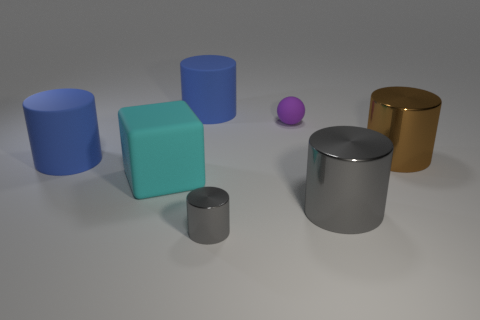Subtract all rubber cylinders. How many cylinders are left? 3 Add 2 green metal spheres. How many objects exist? 9 Subtract all brown cylinders. How many cylinders are left? 4 Subtract all cyan cubes. How many blue cylinders are left? 2 Subtract all blocks. How many objects are left? 6 Subtract 1 blocks. How many blocks are left? 0 Subtract 0 gray blocks. How many objects are left? 7 Subtract all cyan spheres. Subtract all blue cylinders. How many spheres are left? 1 Subtract all large blue rubber balls. Subtract all large cubes. How many objects are left? 6 Add 7 brown metallic things. How many brown metallic things are left? 8 